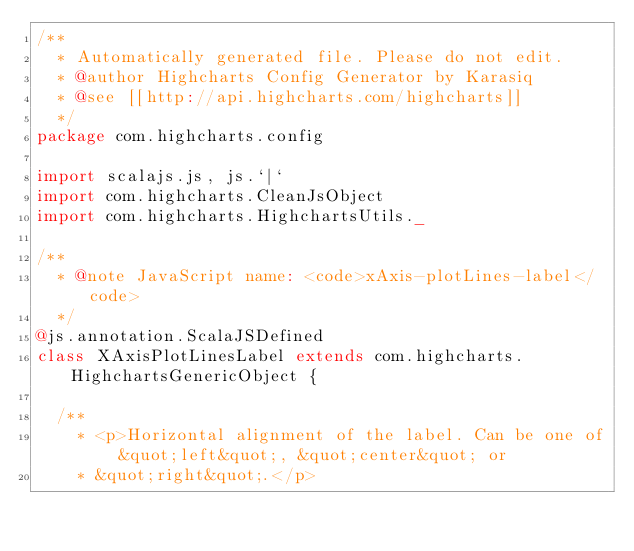Convert code to text. <code><loc_0><loc_0><loc_500><loc_500><_Scala_>/**
  * Automatically generated file. Please do not edit.
  * @author Highcharts Config Generator by Karasiq
  * @see [[http://api.highcharts.com/highcharts]]
  */
package com.highcharts.config

import scalajs.js, js.`|`
import com.highcharts.CleanJsObject
import com.highcharts.HighchartsUtils._

/**
  * @note JavaScript name: <code>xAxis-plotLines-label</code>
  */
@js.annotation.ScalaJSDefined
class XAxisPlotLinesLabel extends com.highcharts.HighchartsGenericObject {

  /**
    * <p>Horizontal alignment of the label. Can be one of &quot;left&quot;, &quot;center&quot; or
    * &quot;right&quot;.</p></code> 